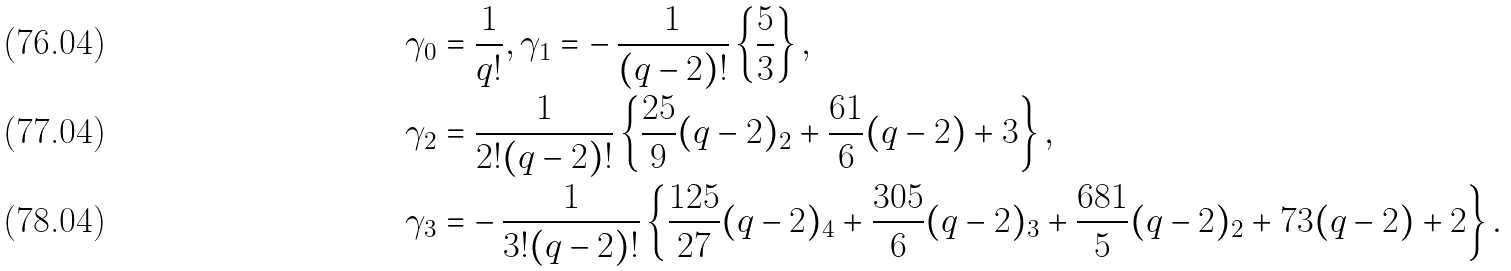Convert formula to latex. <formula><loc_0><loc_0><loc_500><loc_500>\gamma _ { 0 } & = \frac { 1 } { q ! } , \gamma _ { 1 } = - \, \frac { 1 } { ( q - 2 ) ! } \left \{ \frac { 5 } { 3 } \right \} , \\ \gamma _ { 2 } & = \frac { 1 } { 2 ! ( q - 2 ) ! } \left \{ \frac { 2 5 } { 9 } ( q - 2 ) _ { 2 } + \frac { 6 1 } { 6 } ( q - 2 ) + 3 \right \} , \\ \gamma _ { 3 } & = - \, \frac { 1 } { 3 ! ( q - 2 ) ! } \left \{ \frac { 1 2 5 } { 2 7 } ( q - 2 ) _ { 4 } + \frac { 3 0 5 } { 6 } ( q - 2 ) _ { 3 } + \frac { 6 8 1 } { 5 } ( q - 2 ) _ { 2 } + 7 3 ( q - 2 ) + 2 \right \} .</formula> 